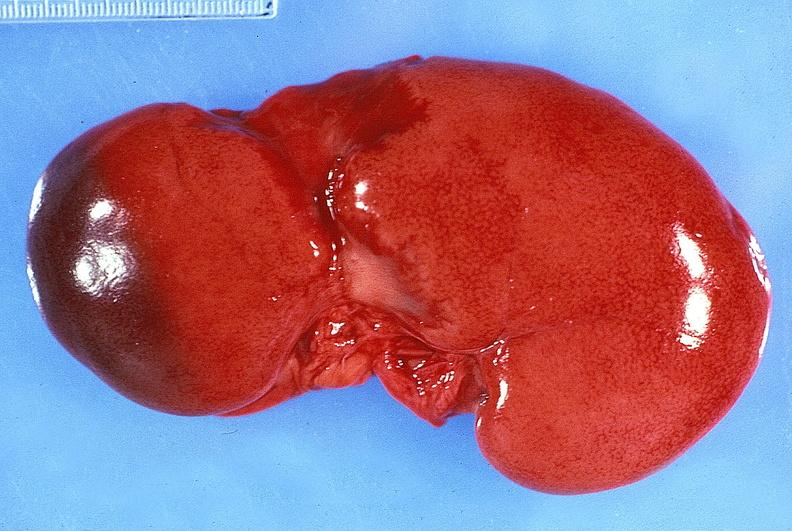where is this?
Answer the question using a single word or phrase. Urinary 